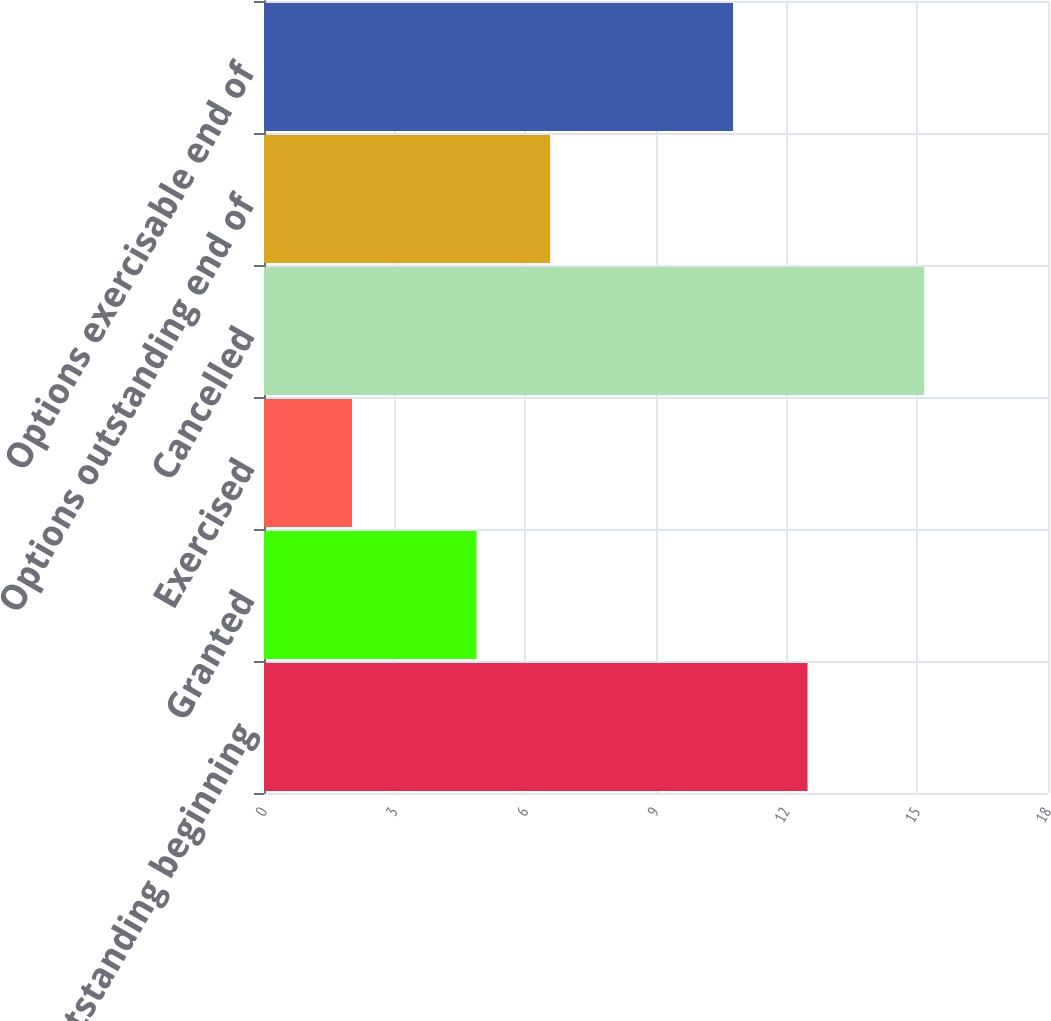Convert chart. <chart><loc_0><loc_0><loc_500><loc_500><bar_chart><fcel>Options outstanding beginning<fcel>Granted<fcel>Exercised<fcel>Cancelled<fcel>Options outstanding end of<fcel>Options exercisable end of<nl><fcel>12.48<fcel>4.88<fcel>2.02<fcel>15.16<fcel>6.57<fcel>10.77<nl></chart> 